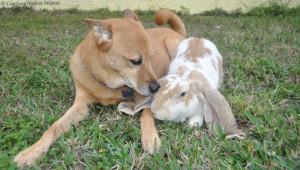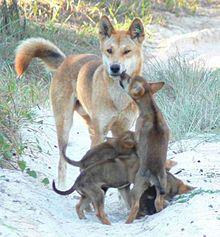The first image is the image on the left, the second image is the image on the right. For the images shown, is this caption "An image shows a wild dog with its nose pointed toward a rabbit-type animal on green grass." true? Answer yes or no. Yes. The first image is the image on the left, the second image is the image on the right. Analyze the images presented: Is the assertion "There is at least one dingo dog laying down." valid? Answer yes or no. Yes. 